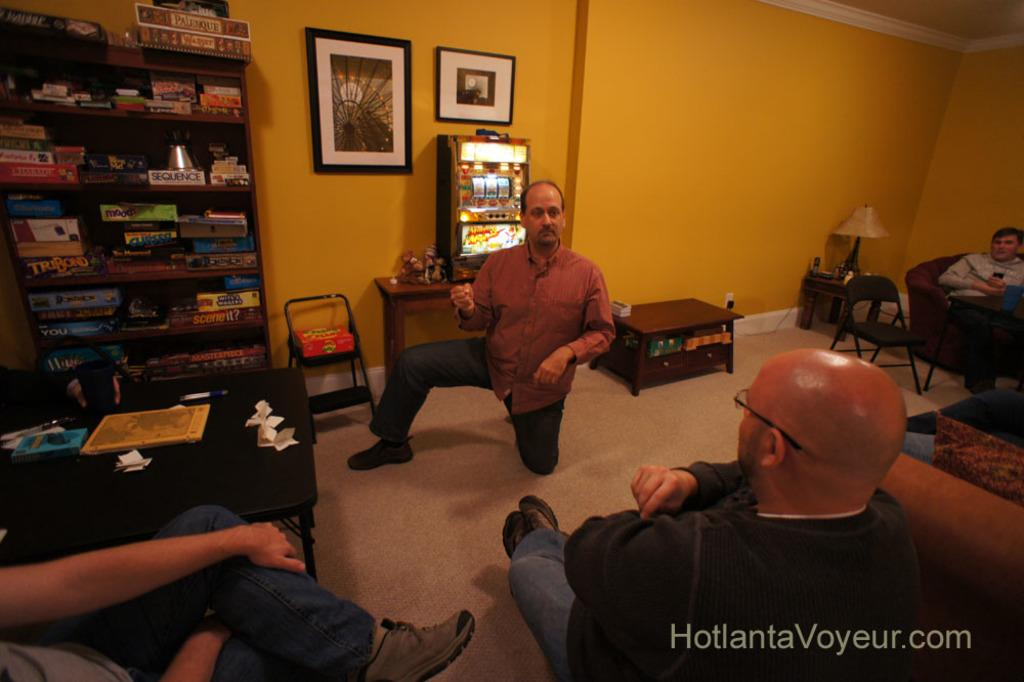What are the people in the image doing? The people in the image are sitting on chairs. What can be seen on the wall in the image? There is a shelf on the wall in the image. What items are on the shelf? There are books on the shelf. What type of sheet is covering the books on the shelf? There is no sheet covering the books on the shelf in the image. What is the friction between the chairs and the floor in the image? The friction between the chairs and the floor cannot be determined from the image alone. 